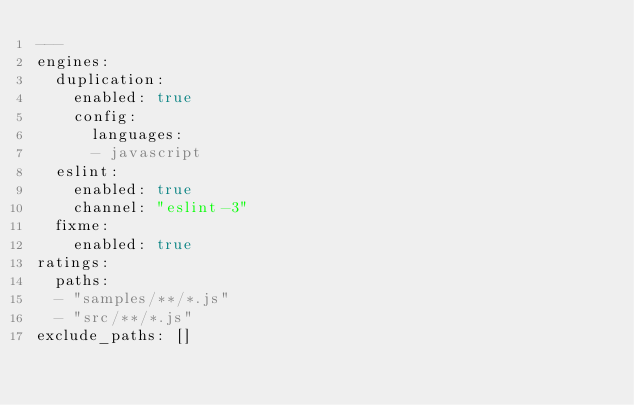<code> <loc_0><loc_0><loc_500><loc_500><_YAML_>---
engines:
  duplication:
    enabled: true
    config:
      languages:
      - javascript
  eslint:
    enabled: true
    channel: "eslint-3"
  fixme:
    enabled: true
ratings:
  paths:
  - "samples/**/*.js"
  - "src/**/*.js"
exclude_paths: []
</code> 